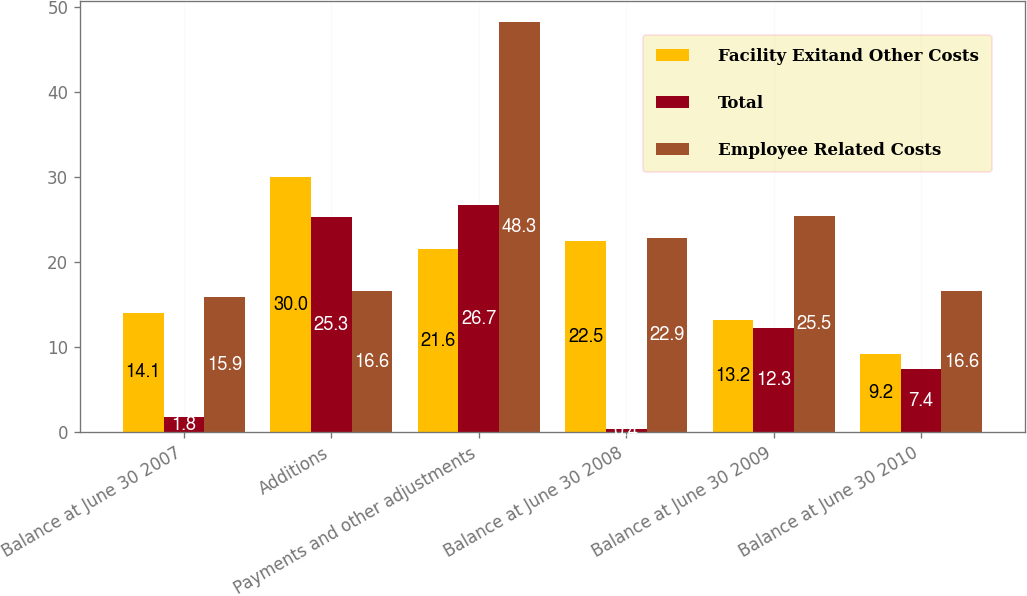Convert chart to OTSL. <chart><loc_0><loc_0><loc_500><loc_500><stacked_bar_chart><ecel><fcel>Balance at June 30 2007<fcel>Additions<fcel>Payments and other adjustments<fcel>Balance at June 30 2008<fcel>Balance at June 30 2009<fcel>Balance at June 30 2010<nl><fcel>Facility Exitand Other Costs<fcel>14.1<fcel>30<fcel>21.6<fcel>22.5<fcel>13.2<fcel>9.2<nl><fcel>Total<fcel>1.8<fcel>25.3<fcel>26.7<fcel>0.4<fcel>12.3<fcel>7.4<nl><fcel>Employee Related Costs<fcel>15.9<fcel>16.6<fcel>48.3<fcel>22.9<fcel>25.5<fcel>16.6<nl></chart> 